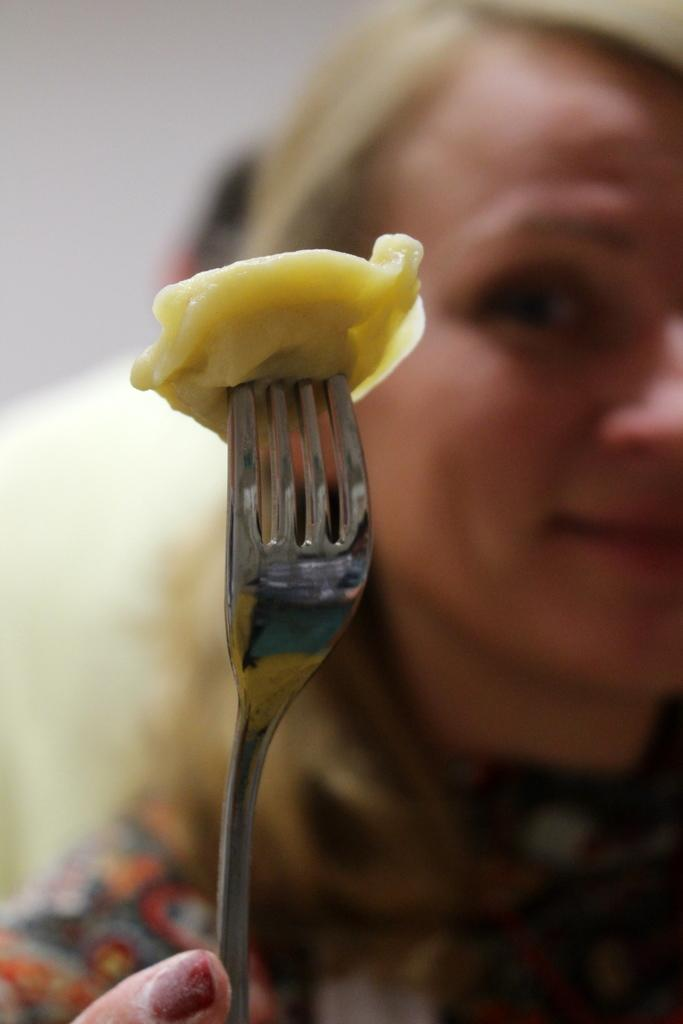Who is the main subject in the image? There is a lady in the image. What is the lady doing in the image? The lady is holding a food item with a fork. Can you describe the person behind the lady? There is a man behind the lady. What type of camp can be seen in the background of the image? There is no camp visible in the image. Is the lady holding a potato with the fork in the image? The food item being held by the lady is not specified as a potato in the provided facts. 